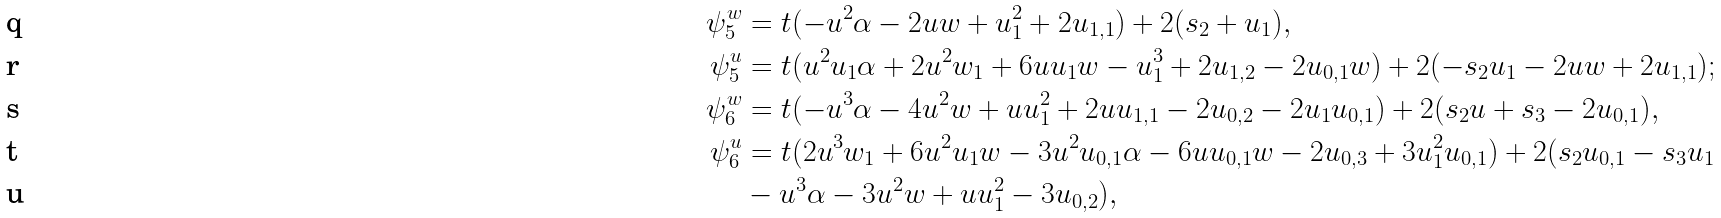Convert formula to latex. <formula><loc_0><loc_0><loc_500><loc_500>\psi ^ { w } _ { 5 } & = t ( - u ^ { 2 } \alpha - 2 u w + u _ { 1 } ^ { 2 } + 2 u _ { 1 , 1 } ) + 2 ( s _ { 2 } + u _ { 1 } ) , \\ \psi ^ { u } _ { 5 } & = t ( u ^ { 2 } u _ { 1 } \alpha + 2 u ^ { 2 } w _ { 1 } + 6 u u _ { 1 } w - u _ { 1 } ^ { 3 } + 2 u _ { 1 , 2 } - 2 u _ { 0 , 1 } w ) + 2 ( - s _ { 2 } u _ { 1 } - 2 u w + 2 u _ { 1 , 1 } ) ; \\ \psi ^ { w } _ { 6 } & = t ( - u ^ { 3 } \alpha - 4 u ^ { 2 } w + u u _ { 1 } ^ { 2 } + 2 u u _ { 1 , 1 } - 2 u _ { 0 , 2 } - 2 u _ { 1 } u _ { 0 , 1 } ) + 2 ( s _ { 2 } u + s _ { 3 } - 2 u _ { 0 , 1 } ) , \\ \psi ^ { u } _ { 6 } & = t ( 2 u ^ { 3 } w _ { 1 } + 6 u ^ { 2 } u _ { 1 } w - 3 u ^ { 2 } u _ { 0 , 1 } \alpha - 6 u u _ { 0 , 1 } w - 2 u _ { 0 , 3 } + 3 u _ { 1 } ^ { 2 } u _ { 0 , 1 } ) + 2 ( s _ { 2 } u _ { 0 , 1 } - s _ { 3 } u _ { 1 } \\ & - u ^ { 3 } \alpha - 3 u ^ { 2 } w + u u _ { 1 } ^ { 2 } - 3 u _ { 0 , 2 } ) ,</formula> 